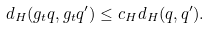<formula> <loc_0><loc_0><loc_500><loc_500>d _ { H } ( g _ { t } q , g _ { t } q ^ { \prime } ) \leq c _ { H } d _ { H } ( q , q ^ { \prime } ) .</formula> 